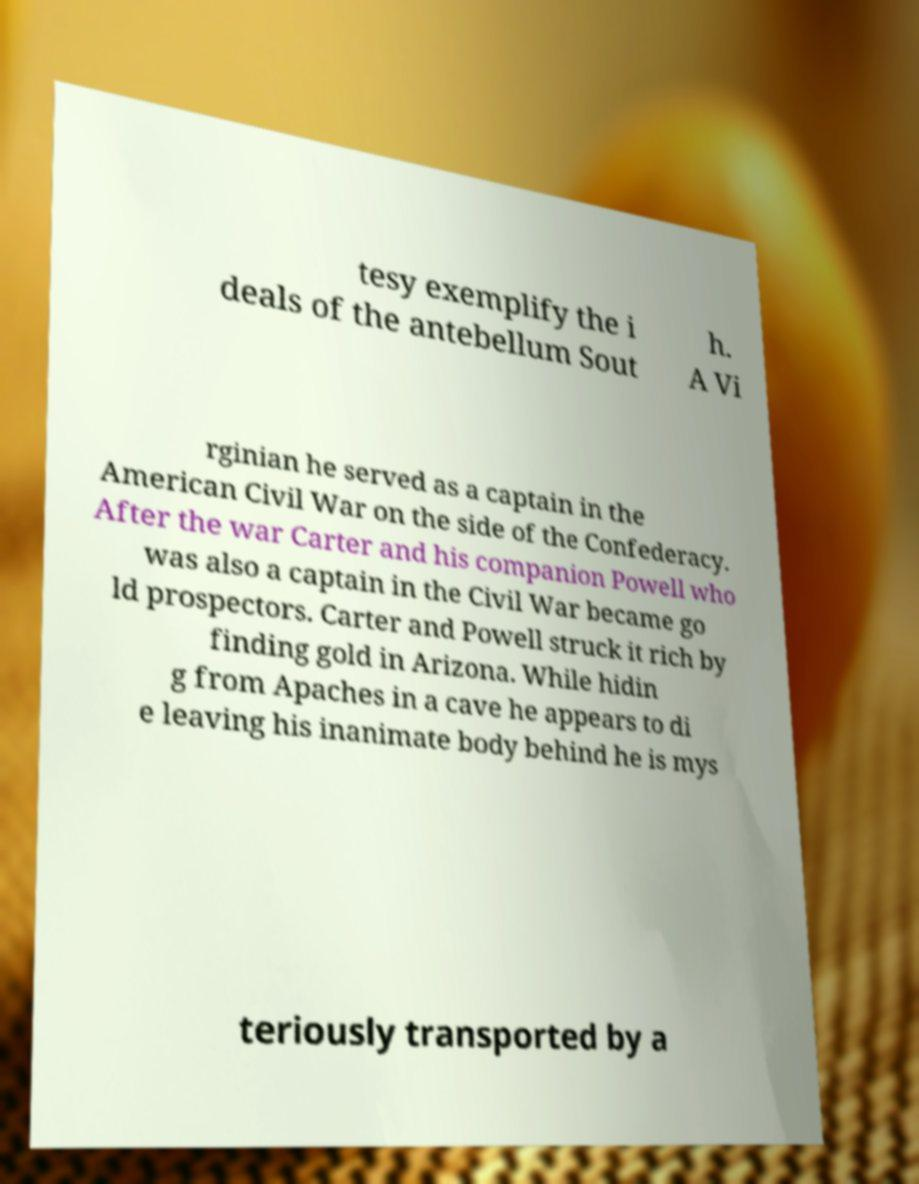Could you assist in decoding the text presented in this image and type it out clearly? tesy exemplify the i deals of the antebellum Sout h. A Vi rginian he served as a captain in the American Civil War on the side of the Confederacy. After the war Carter and his companion Powell who was also a captain in the Civil War became go ld prospectors. Carter and Powell struck it rich by finding gold in Arizona. While hidin g from Apaches in a cave he appears to di e leaving his inanimate body behind he is mys teriously transported by a 